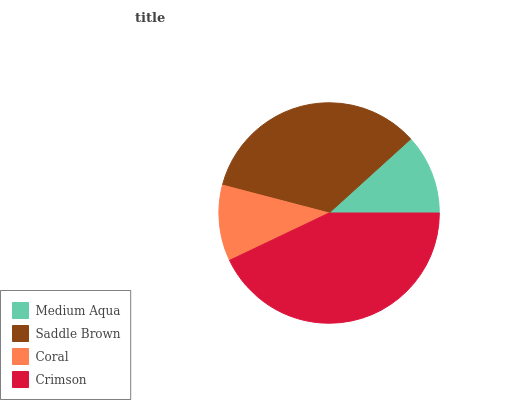Is Coral the minimum?
Answer yes or no. Yes. Is Crimson the maximum?
Answer yes or no. Yes. Is Saddle Brown the minimum?
Answer yes or no. No. Is Saddle Brown the maximum?
Answer yes or no. No. Is Saddle Brown greater than Medium Aqua?
Answer yes or no. Yes. Is Medium Aqua less than Saddle Brown?
Answer yes or no. Yes. Is Medium Aqua greater than Saddle Brown?
Answer yes or no. No. Is Saddle Brown less than Medium Aqua?
Answer yes or no. No. Is Saddle Brown the high median?
Answer yes or no. Yes. Is Medium Aqua the low median?
Answer yes or no. Yes. Is Crimson the high median?
Answer yes or no. No. Is Coral the low median?
Answer yes or no. No. 